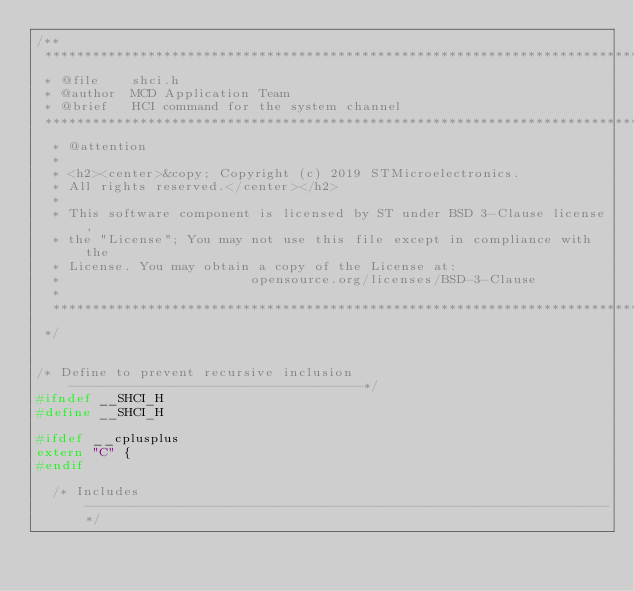<code> <loc_0><loc_0><loc_500><loc_500><_C_>/**
 ******************************************************************************
 * @file    shci.h
 * @author  MCD Application Team
 * @brief   HCI command for the system channel
 ******************************************************************************
  * @attention
  *
  * <h2><center>&copy; Copyright (c) 2019 STMicroelectronics. 
  * All rights reserved.</center></h2>
  *
  * This software component is licensed by ST under BSD 3-Clause license,
  * the "License"; You may not use this file except in compliance with the 
  * License. You may obtain a copy of the License at:
  *                        opensource.org/licenses/BSD-3-Clause
  *
  ******************************************************************************
 */


/* Define to prevent recursive inclusion -------------------------------------*/
#ifndef __SHCI_H
#define __SHCI_H

#ifdef __cplusplus
extern "C" {
#endif

  /* Includes ------------------------------------------------------------------*/</code> 